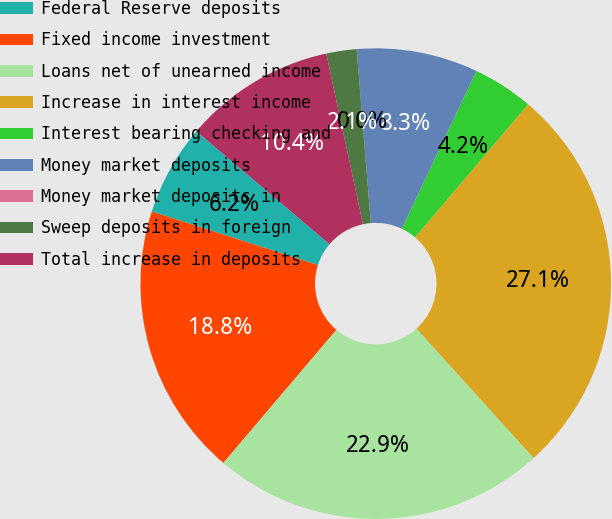Convert chart to OTSL. <chart><loc_0><loc_0><loc_500><loc_500><pie_chart><fcel>Federal Reserve deposits<fcel>Fixed income investment<fcel>Loans net of unearned income<fcel>Increase in interest income<fcel>Interest bearing checking and<fcel>Money market deposits<fcel>Money market deposits in<fcel>Sweep deposits in foreign<fcel>Total increase in deposits<nl><fcel>6.25%<fcel>18.75%<fcel>22.92%<fcel>27.08%<fcel>4.17%<fcel>8.33%<fcel>0.0%<fcel>2.08%<fcel>10.42%<nl></chart> 